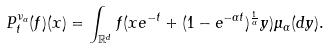<formula> <loc_0><loc_0><loc_500><loc_500>P ^ { \nu _ { \alpha } } _ { t } ( f ) ( x ) = \int _ { \mathbb { R } ^ { d } } f ( x e ^ { - t } + ( 1 - e ^ { - \alpha t } ) ^ { \frac { 1 } { \alpha } } y ) \mu _ { \alpha } ( d y ) .</formula> 